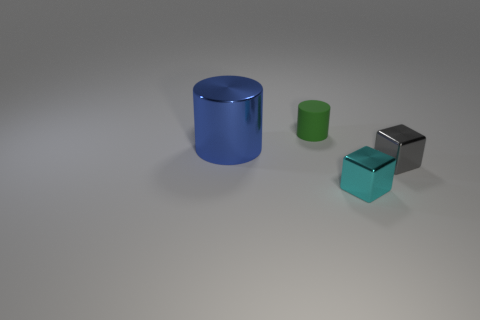Add 1 small matte cylinders. How many objects exist? 5 Subtract 0 brown cylinders. How many objects are left? 4 Subtract all large blue things. Subtract all small cyan cubes. How many objects are left? 2 Add 2 blue shiny objects. How many blue shiny objects are left? 3 Add 4 big purple rubber blocks. How many big purple rubber blocks exist? 4 